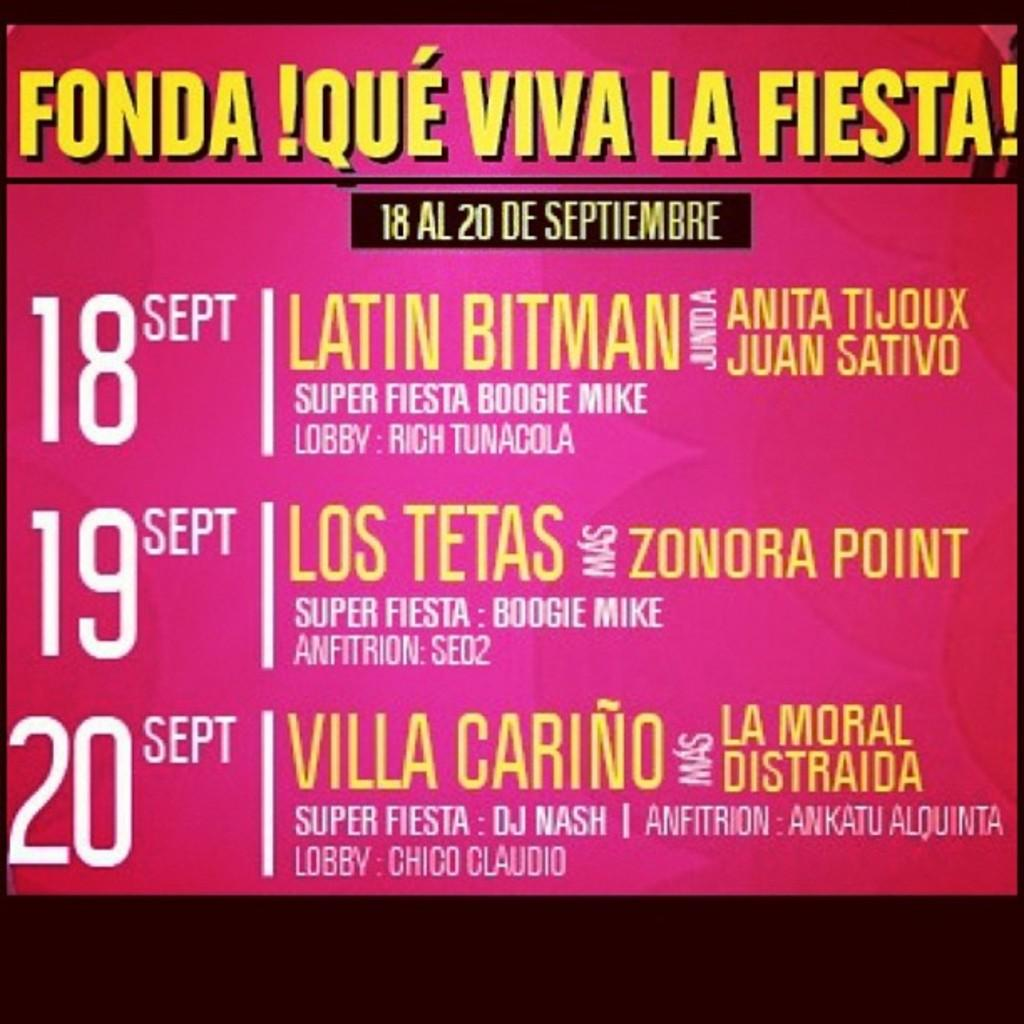<image>
Write a terse but informative summary of the picture. A sign that says Fonda Que Viva La Fiesta. 